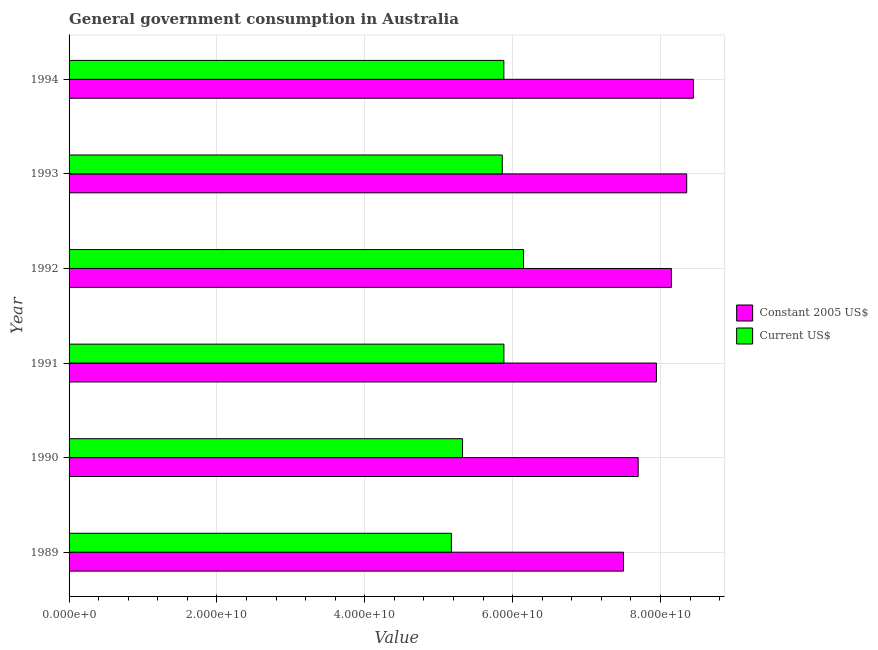How many different coloured bars are there?
Make the answer very short. 2. What is the label of the 1st group of bars from the top?
Provide a succinct answer. 1994. What is the value consumed in constant 2005 us$ in 1989?
Provide a succinct answer. 7.50e+1. Across all years, what is the maximum value consumed in constant 2005 us$?
Provide a short and direct response. 8.44e+1. Across all years, what is the minimum value consumed in current us$?
Your response must be concise. 5.17e+1. In which year was the value consumed in constant 2005 us$ maximum?
Your answer should be compact. 1994. What is the total value consumed in constant 2005 us$ in the graph?
Offer a very short reply. 4.81e+11. What is the difference between the value consumed in constant 2005 us$ in 1990 and that in 1992?
Offer a very short reply. -4.49e+09. What is the difference between the value consumed in constant 2005 us$ in 1990 and the value consumed in current us$ in 1993?
Offer a terse response. 1.84e+1. What is the average value consumed in constant 2005 us$ per year?
Provide a succinct answer. 8.01e+1. In the year 1992, what is the difference between the value consumed in current us$ and value consumed in constant 2005 us$?
Make the answer very short. -2.00e+1. What is the ratio of the value consumed in current us$ in 1991 to that in 1993?
Provide a succinct answer. 1. Is the value consumed in constant 2005 us$ in 1989 less than that in 1994?
Your response must be concise. Yes. Is the difference between the value consumed in constant 2005 us$ in 1991 and 1992 greater than the difference between the value consumed in current us$ in 1991 and 1992?
Your response must be concise. Yes. What is the difference between the highest and the second highest value consumed in current us$?
Your answer should be compact. 2.65e+09. What is the difference between the highest and the lowest value consumed in current us$?
Provide a succinct answer. 9.76e+09. In how many years, is the value consumed in constant 2005 us$ greater than the average value consumed in constant 2005 us$ taken over all years?
Make the answer very short. 3. Is the sum of the value consumed in constant 2005 us$ in 1989 and 1993 greater than the maximum value consumed in current us$ across all years?
Ensure brevity in your answer.  Yes. What does the 2nd bar from the top in 1993 represents?
Provide a succinct answer. Constant 2005 US$. What does the 1st bar from the bottom in 1994 represents?
Provide a short and direct response. Constant 2005 US$. Are all the bars in the graph horizontal?
Your answer should be compact. Yes. How many years are there in the graph?
Provide a succinct answer. 6. Does the graph contain any zero values?
Provide a succinct answer. No. How many legend labels are there?
Provide a succinct answer. 2. How are the legend labels stacked?
Make the answer very short. Vertical. What is the title of the graph?
Keep it short and to the point. General government consumption in Australia. What is the label or title of the X-axis?
Give a very brief answer. Value. What is the Value of Constant 2005 US$ in 1989?
Offer a terse response. 7.50e+1. What is the Value in Current US$ in 1989?
Your answer should be very brief. 5.17e+1. What is the Value in Constant 2005 US$ in 1990?
Provide a short and direct response. 7.70e+1. What is the Value in Current US$ in 1990?
Provide a short and direct response. 5.32e+1. What is the Value in Constant 2005 US$ in 1991?
Ensure brevity in your answer.  7.94e+1. What is the Value of Current US$ in 1991?
Your answer should be compact. 5.88e+1. What is the Value in Constant 2005 US$ in 1992?
Your answer should be compact. 8.15e+1. What is the Value of Current US$ in 1992?
Your answer should be compact. 6.15e+1. What is the Value in Constant 2005 US$ in 1993?
Your response must be concise. 8.35e+1. What is the Value in Current US$ in 1993?
Offer a very short reply. 5.86e+1. What is the Value in Constant 2005 US$ in 1994?
Offer a very short reply. 8.44e+1. What is the Value in Current US$ in 1994?
Ensure brevity in your answer.  5.88e+1. Across all years, what is the maximum Value in Constant 2005 US$?
Give a very brief answer. 8.44e+1. Across all years, what is the maximum Value in Current US$?
Your response must be concise. 6.15e+1. Across all years, what is the minimum Value of Constant 2005 US$?
Provide a short and direct response. 7.50e+1. Across all years, what is the minimum Value in Current US$?
Your response must be concise. 5.17e+1. What is the total Value in Constant 2005 US$ in the graph?
Your answer should be very brief. 4.81e+11. What is the total Value in Current US$ in the graph?
Make the answer very short. 3.43e+11. What is the difference between the Value in Constant 2005 US$ in 1989 and that in 1990?
Offer a terse response. -1.99e+09. What is the difference between the Value of Current US$ in 1989 and that in 1990?
Your response must be concise. -1.51e+09. What is the difference between the Value of Constant 2005 US$ in 1989 and that in 1991?
Your answer should be very brief. -4.45e+09. What is the difference between the Value of Current US$ in 1989 and that in 1991?
Offer a very short reply. -7.10e+09. What is the difference between the Value in Constant 2005 US$ in 1989 and that in 1992?
Your answer should be very brief. -6.48e+09. What is the difference between the Value of Current US$ in 1989 and that in 1992?
Make the answer very short. -9.76e+09. What is the difference between the Value of Constant 2005 US$ in 1989 and that in 1993?
Offer a very short reply. -8.55e+09. What is the difference between the Value in Current US$ in 1989 and that in 1993?
Offer a terse response. -6.88e+09. What is the difference between the Value in Constant 2005 US$ in 1989 and that in 1994?
Offer a very short reply. -9.46e+09. What is the difference between the Value of Current US$ in 1989 and that in 1994?
Your response must be concise. -7.10e+09. What is the difference between the Value in Constant 2005 US$ in 1990 and that in 1991?
Provide a short and direct response. -2.46e+09. What is the difference between the Value of Current US$ in 1990 and that in 1991?
Give a very brief answer. -5.59e+09. What is the difference between the Value of Constant 2005 US$ in 1990 and that in 1992?
Give a very brief answer. -4.49e+09. What is the difference between the Value of Current US$ in 1990 and that in 1992?
Your response must be concise. -8.24e+09. What is the difference between the Value of Constant 2005 US$ in 1990 and that in 1993?
Your answer should be compact. -6.56e+09. What is the difference between the Value in Current US$ in 1990 and that in 1993?
Offer a terse response. -5.37e+09. What is the difference between the Value of Constant 2005 US$ in 1990 and that in 1994?
Offer a very short reply. -7.47e+09. What is the difference between the Value in Current US$ in 1990 and that in 1994?
Your response must be concise. -5.59e+09. What is the difference between the Value in Constant 2005 US$ in 1991 and that in 1992?
Give a very brief answer. -2.03e+09. What is the difference between the Value of Current US$ in 1991 and that in 1992?
Your answer should be very brief. -2.65e+09. What is the difference between the Value in Constant 2005 US$ in 1991 and that in 1993?
Make the answer very short. -4.10e+09. What is the difference between the Value of Current US$ in 1991 and that in 1993?
Ensure brevity in your answer.  2.22e+08. What is the difference between the Value of Constant 2005 US$ in 1991 and that in 1994?
Keep it short and to the point. -5.00e+09. What is the difference between the Value in Current US$ in 1991 and that in 1994?
Offer a terse response. 7.93e+06. What is the difference between the Value in Constant 2005 US$ in 1992 and that in 1993?
Ensure brevity in your answer.  -2.07e+09. What is the difference between the Value in Current US$ in 1992 and that in 1993?
Your response must be concise. 2.87e+09. What is the difference between the Value of Constant 2005 US$ in 1992 and that in 1994?
Your response must be concise. -2.98e+09. What is the difference between the Value in Current US$ in 1992 and that in 1994?
Your response must be concise. 2.66e+09. What is the difference between the Value of Constant 2005 US$ in 1993 and that in 1994?
Give a very brief answer. -9.08e+08. What is the difference between the Value in Current US$ in 1993 and that in 1994?
Your response must be concise. -2.14e+08. What is the difference between the Value in Constant 2005 US$ in 1989 and the Value in Current US$ in 1990?
Provide a short and direct response. 2.18e+1. What is the difference between the Value in Constant 2005 US$ in 1989 and the Value in Current US$ in 1991?
Make the answer very short. 1.62e+1. What is the difference between the Value in Constant 2005 US$ in 1989 and the Value in Current US$ in 1992?
Offer a very short reply. 1.35e+1. What is the difference between the Value of Constant 2005 US$ in 1989 and the Value of Current US$ in 1993?
Offer a terse response. 1.64e+1. What is the difference between the Value in Constant 2005 US$ in 1989 and the Value in Current US$ in 1994?
Give a very brief answer. 1.62e+1. What is the difference between the Value of Constant 2005 US$ in 1990 and the Value of Current US$ in 1991?
Offer a terse response. 1.82e+1. What is the difference between the Value in Constant 2005 US$ in 1990 and the Value in Current US$ in 1992?
Offer a terse response. 1.55e+1. What is the difference between the Value in Constant 2005 US$ in 1990 and the Value in Current US$ in 1993?
Your answer should be very brief. 1.84e+1. What is the difference between the Value of Constant 2005 US$ in 1990 and the Value of Current US$ in 1994?
Your response must be concise. 1.82e+1. What is the difference between the Value of Constant 2005 US$ in 1991 and the Value of Current US$ in 1992?
Offer a very short reply. 1.80e+1. What is the difference between the Value of Constant 2005 US$ in 1991 and the Value of Current US$ in 1993?
Your answer should be compact. 2.08e+1. What is the difference between the Value of Constant 2005 US$ in 1991 and the Value of Current US$ in 1994?
Give a very brief answer. 2.06e+1. What is the difference between the Value of Constant 2005 US$ in 1992 and the Value of Current US$ in 1993?
Your answer should be very brief. 2.29e+1. What is the difference between the Value of Constant 2005 US$ in 1992 and the Value of Current US$ in 1994?
Keep it short and to the point. 2.27e+1. What is the difference between the Value in Constant 2005 US$ in 1993 and the Value in Current US$ in 1994?
Provide a short and direct response. 2.47e+1. What is the average Value in Constant 2005 US$ per year?
Keep it short and to the point. 8.01e+1. What is the average Value in Current US$ per year?
Offer a very short reply. 5.71e+1. In the year 1989, what is the difference between the Value of Constant 2005 US$ and Value of Current US$?
Make the answer very short. 2.33e+1. In the year 1990, what is the difference between the Value in Constant 2005 US$ and Value in Current US$?
Ensure brevity in your answer.  2.38e+1. In the year 1991, what is the difference between the Value of Constant 2005 US$ and Value of Current US$?
Your answer should be very brief. 2.06e+1. In the year 1992, what is the difference between the Value in Constant 2005 US$ and Value in Current US$?
Offer a very short reply. 2.00e+1. In the year 1993, what is the difference between the Value in Constant 2005 US$ and Value in Current US$?
Provide a succinct answer. 2.49e+1. In the year 1994, what is the difference between the Value in Constant 2005 US$ and Value in Current US$?
Offer a very short reply. 2.56e+1. What is the ratio of the Value of Constant 2005 US$ in 1989 to that in 1990?
Your answer should be compact. 0.97. What is the ratio of the Value of Current US$ in 1989 to that in 1990?
Keep it short and to the point. 0.97. What is the ratio of the Value of Constant 2005 US$ in 1989 to that in 1991?
Your response must be concise. 0.94. What is the ratio of the Value in Current US$ in 1989 to that in 1991?
Your response must be concise. 0.88. What is the ratio of the Value in Constant 2005 US$ in 1989 to that in 1992?
Provide a short and direct response. 0.92. What is the ratio of the Value of Current US$ in 1989 to that in 1992?
Offer a terse response. 0.84. What is the ratio of the Value in Constant 2005 US$ in 1989 to that in 1993?
Ensure brevity in your answer.  0.9. What is the ratio of the Value in Current US$ in 1989 to that in 1993?
Make the answer very short. 0.88. What is the ratio of the Value in Constant 2005 US$ in 1989 to that in 1994?
Make the answer very short. 0.89. What is the ratio of the Value of Current US$ in 1989 to that in 1994?
Ensure brevity in your answer.  0.88. What is the ratio of the Value in Constant 2005 US$ in 1990 to that in 1991?
Provide a short and direct response. 0.97. What is the ratio of the Value of Current US$ in 1990 to that in 1991?
Ensure brevity in your answer.  0.9. What is the ratio of the Value of Constant 2005 US$ in 1990 to that in 1992?
Ensure brevity in your answer.  0.94. What is the ratio of the Value in Current US$ in 1990 to that in 1992?
Ensure brevity in your answer.  0.87. What is the ratio of the Value in Constant 2005 US$ in 1990 to that in 1993?
Offer a terse response. 0.92. What is the ratio of the Value of Current US$ in 1990 to that in 1993?
Offer a terse response. 0.91. What is the ratio of the Value of Constant 2005 US$ in 1990 to that in 1994?
Your answer should be very brief. 0.91. What is the ratio of the Value of Current US$ in 1990 to that in 1994?
Provide a short and direct response. 0.91. What is the ratio of the Value of Constant 2005 US$ in 1991 to that in 1992?
Ensure brevity in your answer.  0.98. What is the ratio of the Value of Current US$ in 1991 to that in 1992?
Keep it short and to the point. 0.96. What is the ratio of the Value in Constant 2005 US$ in 1991 to that in 1993?
Ensure brevity in your answer.  0.95. What is the ratio of the Value of Current US$ in 1991 to that in 1993?
Your answer should be very brief. 1. What is the ratio of the Value of Constant 2005 US$ in 1991 to that in 1994?
Give a very brief answer. 0.94. What is the ratio of the Value of Current US$ in 1991 to that in 1994?
Ensure brevity in your answer.  1. What is the ratio of the Value of Constant 2005 US$ in 1992 to that in 1993?
Offer a very short reply. 0.98. What is the ratio of the Value of Current US$ in 1992 to that in 1993?
Offer a terse response. 1.05. What is the ratio of the Value of Constant 2005 US$ in 1992 to that in 1994?
Ensure brevity in your answer.  0.96. What is the ratio of the Value in Current US$ in 1992 to that in 1994?
Provide a succinct answer. 1.05. What is the ratio of the Value in Constant 2005 US$ in 1993 to that in 1994?
Your answer should be compact. 0.99. What is the ratio of the Value in Current US$ in 1993 to that in 1994?
Keep it short and to the point. 1. What is the difference between the highest and the second highest Value in Constant 2005 US$?
Offer a very short reply. 9.08e+08. What is the difference between the highest and the second highest Value of Current US$?
Make the answer very short. 2.65e+09. What is the difference between the highest and the lowest Value of Constant 2005 US$?
Make the answer very short. 9.46e+09. What is the difference between the highest and the lowest Value in Current US$?
Offer a very short reply. 9.76e+09. 